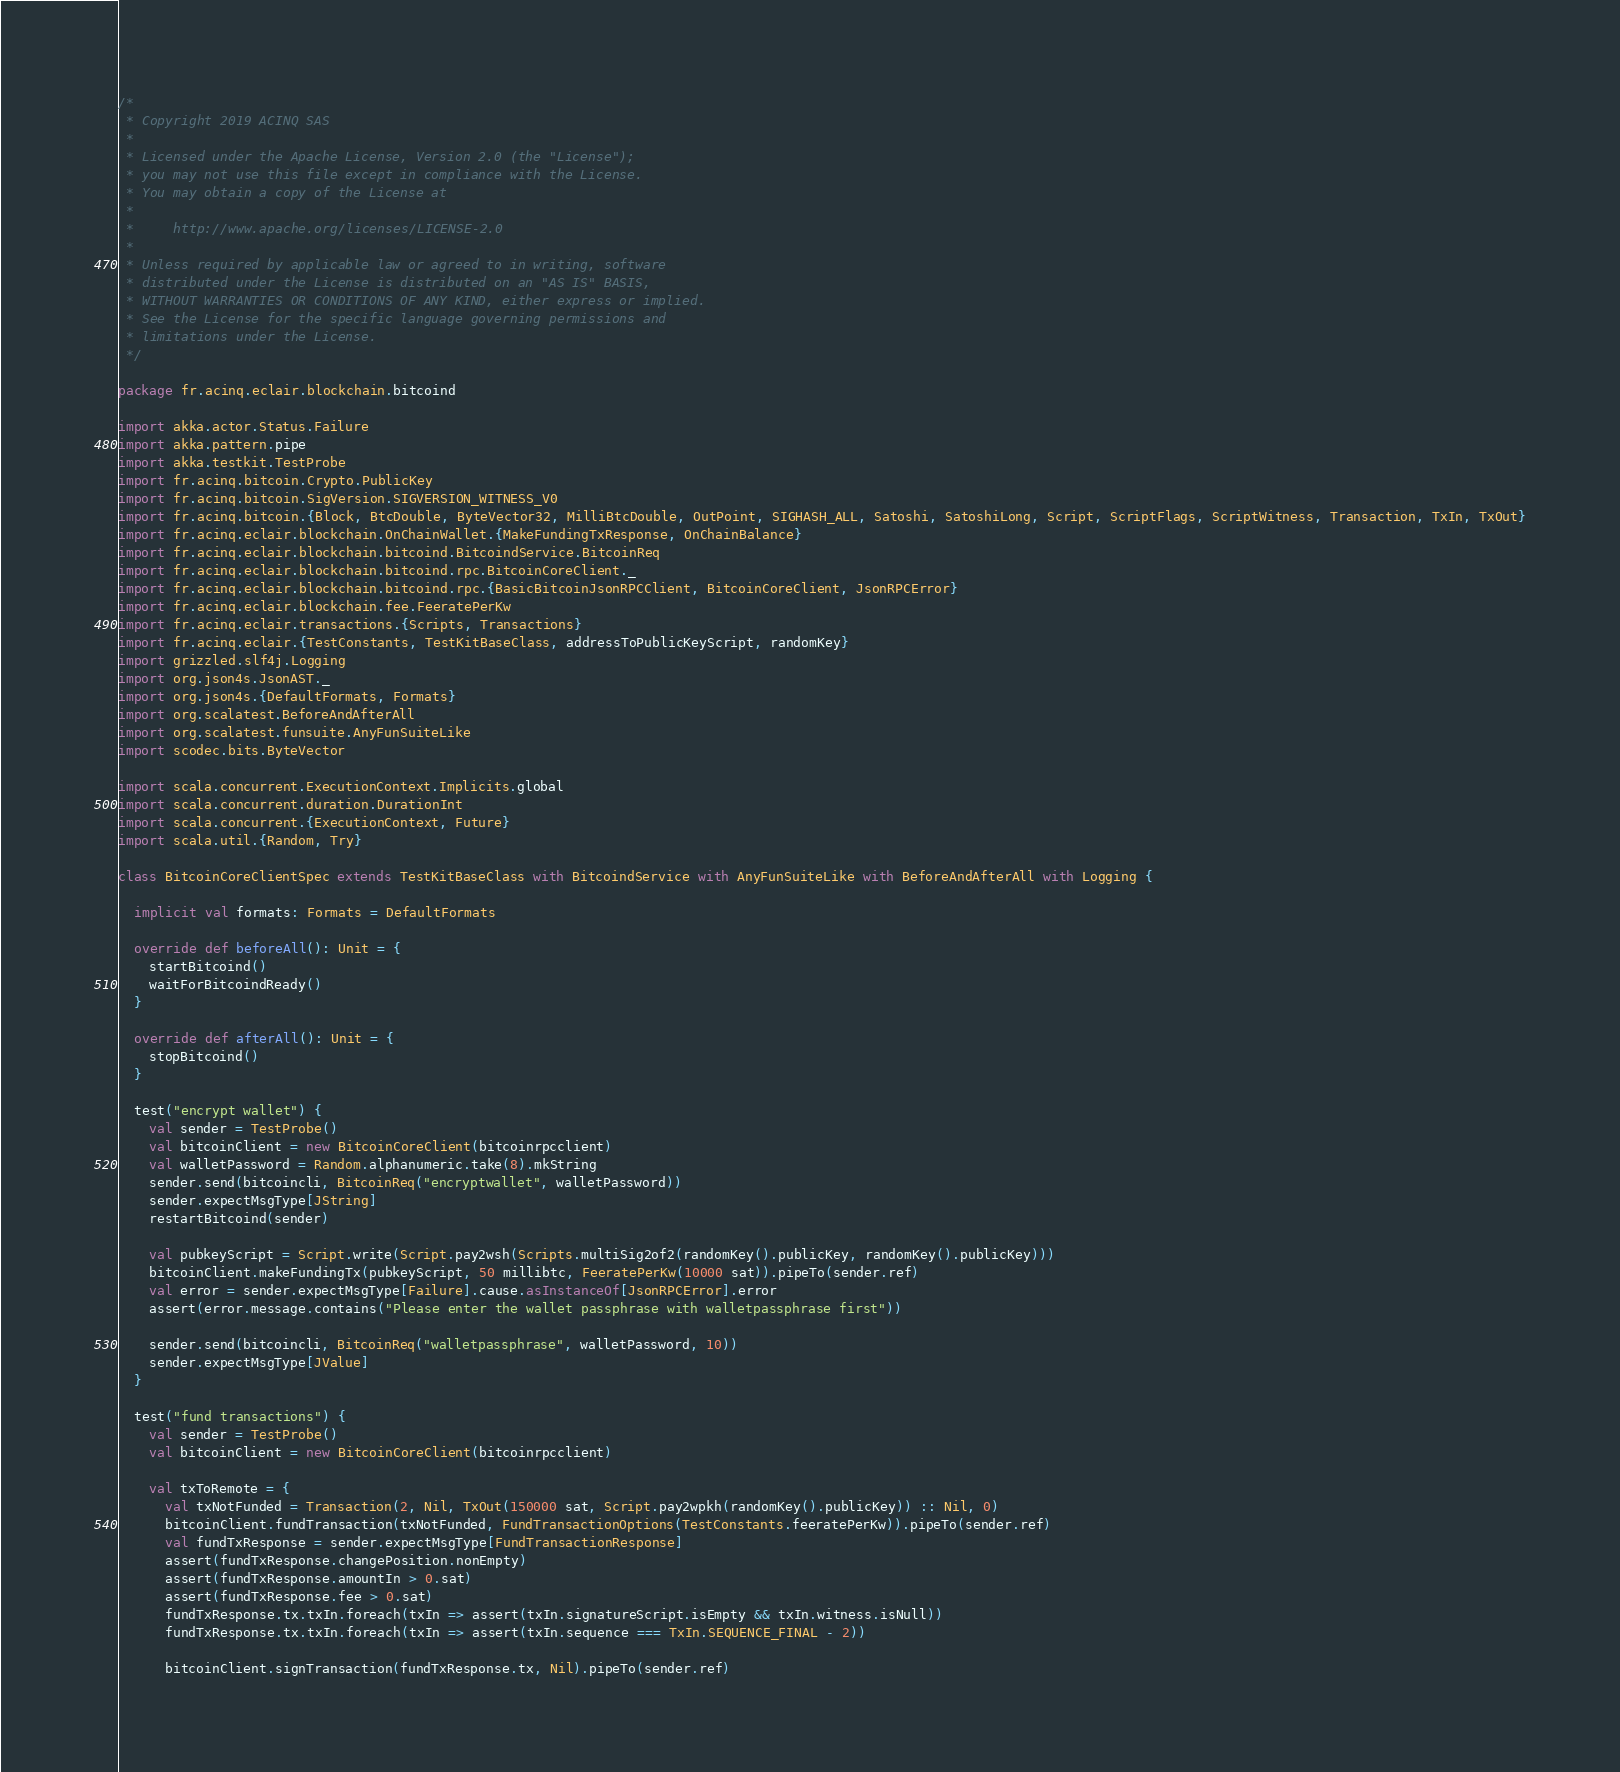Convert code to text. <code><loc_0><loc_0><loc_500><loc_500><_Scala_>/*
 * Copyright 2019 ACINQ SAS
 *
 * Licensed under the Apache License, Version 2.0 (the "License");
 * you may not use this file except in compliance with the License.
 * You may obtain a copy of the License at
 *
 *     http://www.apache.org/licenses/LICENSE-2.0
 *
 * Unless required by applicable law or agreed to in writing, software
 * distributed under the License is distributed on an "AS IS" BASIS,
 * WITHOUT WARRANTIES OR CONDITIONS OF ANY KIND, either express or implied.
 * See the License for the specific language governing permissions and
 * limitations under the License.
 */

package fr.acinq.eclair.blockchain.bitcoind

import akka.actor.Status.Failure
import akka.pattern.pipe
import akka.testkit.TestProbe
import fr.acinq.bitcoin.Crypto.PublicKey
import fr.acinq.bitcoin.SigVersion.SIGVERSION_WITNESS_V0
import fr.acinq.bitcoin.{Block, BtcDouble, ByteVector32, MilliBtcDouble, OutPoint, SIGHASH_ALL, Satoshi, SatoshiLong, Script, ScriptFlags, ScriptWitness, Transaction, TxIn, TxOut}
import fr.acinq.eclair.blockchain.OnChainWallet.{MakeFundingTxResponse, OnChainBalance}
import fr.acinq.eclair.blockchain.bitcoind.BitcoindService.BitcoinReq
import fr.acinq.eclair.blockchain.bitcoind.rpc.BitcoinCoreClient._
import fr.acinq.eclair.blockchain.bitcoind.rpc.{BasicBitcoinJsonRPCClient, BitcoinCoreClient, JsonRPCError}
import fr.acinq.eclair.blockchain.fee.FeeratePerKw
import fr.acinq.eclair.transactions.{Scripts, Transactions}
import fr.acinq.eclair.{TestConstants, TestKitBaseClass, addressToPublicKeyScript, randomKey}
import grizzled.slf4j.Logging
import org.json4s.JsonAST._
import org.json4s.{DefaultFormats, Formats}
import org.scalatest.BeforeAndAfterAll
import org.scalatest.funsuite.AnyFunSuiteLike
import scodec.bits.ByteVector

import scala.concurrent.ExecutionContext.Implicits.global
import scala.concurrent.duration.DurationInt
import scala.concurrent.{ExecutionContext, Future}
import scala.util.{Random, Try}

class BitcoinCoreClientSpec extends TestKitBaseClass with BitcoindService with AnyFunSuiteLike with BeforeAndAfterAll with Logging {

  implicit val formats: Formats = DefaultFormats

  override def beforeAll(): Unit = {
    startBitcoind()
    waitForBitcoindReady()
  }

  override def afterAll(): Unit = {
    stopBitcoind()
  }

  test("encrypt wallet") {
    val sender = TestProbe()
    val bitcoinClient = new BitcoinCoreClient(bitcoinrpcclient)
    val walletPassword = Random.alphanumeric.take(8).mkString
    sender.send(bitcoincli, BitcoinReq("encryptwallet", walletPassword))
    sender.expectMsgType[JString]
    restartBitcoind(sender)

    val pubkeyScript = Script.write(Script.pay2wsh(Scripts.multiSig2of2(randomKey().publicKey, randomKey().publicKey)))
    bitcoinClient.makeFundingTx(pubkeyScript, 50 millibtc, FeeratePerKw(10000 sat)).pipeTo(sender.ref)
    val error = sender.expectMsgType[Failure].cause.asInstanceOf[JsonRPCError].error
    assert(error.message.contains("Please enter the wallet passphrase with walletpassphrase first"))

    sender.send(bitcoincli, BitcoinReq("walletpassphrase", walletPassword, 10))
    sender.expectMsgType[JValue]
  }

  test("fund transactions") {
    val sender = TestProbe()
    val bitcoinClient = new BitcoinCoreClient(bitcoinrpcclient)

    val txToRemote = {
      val txNotFunded = Transaction(2, Nil, TxOut(150000 sat, Script.pay2wpkh(randomKey().publicKey)) :: Nil, 0)
      bitcoinClient.fundTransaction(txNotFunded, FundTransactionOptions(TestConstants.feeratePerKw)).pipeTo(sender.ref)
      val fundTxResponse = sender.expectMsgType[FundTransactionResponse]
      assert(fundTxResponse.changePosition.nonEmpty)
      assert(fundTxResponse.amountIn > 0.sat)
      assert(fundTxResponse.fee > 0.sat)
      fundTxResponse.tx.txIn.foreach(txIn => assert(txIn.signatureScript.isEmpty && txIn.witness.isNull))
      fundTxResponse.tx.txIn.foreach(txIn => assert(txIn.sequence === TxIn.SEQUENCE_FINAL - 2))

      bitcoinClient.signTransaction(fundTxResponse.tx, Nil).pipeTo(sender.ref)</code> 